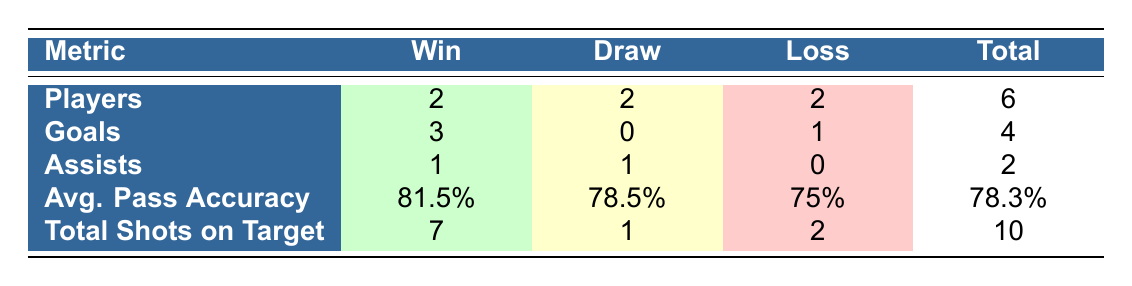What is the total number of players who participated in matches resulting in a win? There are 2 players listed under the "Win" category in the table. This can be found directly by looking at the "Players" row under the "Win" column.
Answer: 2 What is the total number of goals scored by players in matches that ended in a draw? There were no goals scored by players in the "Draw" category as indicated in the "Goals" row under the "Draw" column.
Answer: 0 Which match outcome had the highest average pass accuracy? To find the highest average pass accuracy, we compare the values in the "Avg. Pass Accuracy" row: 81.5% for "Win," 78.5% for "Draw," and 75% for "Loss." The highest value is 81.5%, which corresponds to matches that resulted in a win.
Answer: Win How many more total shots on target were recorded in matches that ended in a win compared to those that ended in a loss? The total shots on target for "Win" is 7 and for "Loss" is 2. The difference is 7 - 2 = 5. Therefore, there were 5 more shots on target in win matches compared to loss matches.
Answer: 5 Is it true that players achieved a higher total number of assists in matches that ended in a draw than in matches that ended in a loss? In the "Draw" category, players made 1 assist, while in the "Loss" category, they made 0 assists. Since 1 is greater than 0, the statement is true.
Answer: Yes Which match outcome had the least total of shots on target? The "Loss" outcome had a total of 2 shots on target, which is the lowest when compared to "Win" with 7 and "Draw" with 1.
Answer: Loss What is the total number of assists made by players in matches that ended in a win and draw combined? For "Win," there is 1 assist, and for "Draw," again, there is 1 assist. Combining these gives us 1 + 1 = 2 total assists in matches that ended in either a win or a draw.
Answer: 2 What is the average pass accuracy for all matches combined? The average pass accuracy for the total matches combines the individual averages: (81.5% + 78.5% + 75%) divided by 3 matches. First, sum the values: 81.5 + 78.5 + 75 = 235. Then divide: 235 / 3 = 78.3%.
Answer: 78.3% 